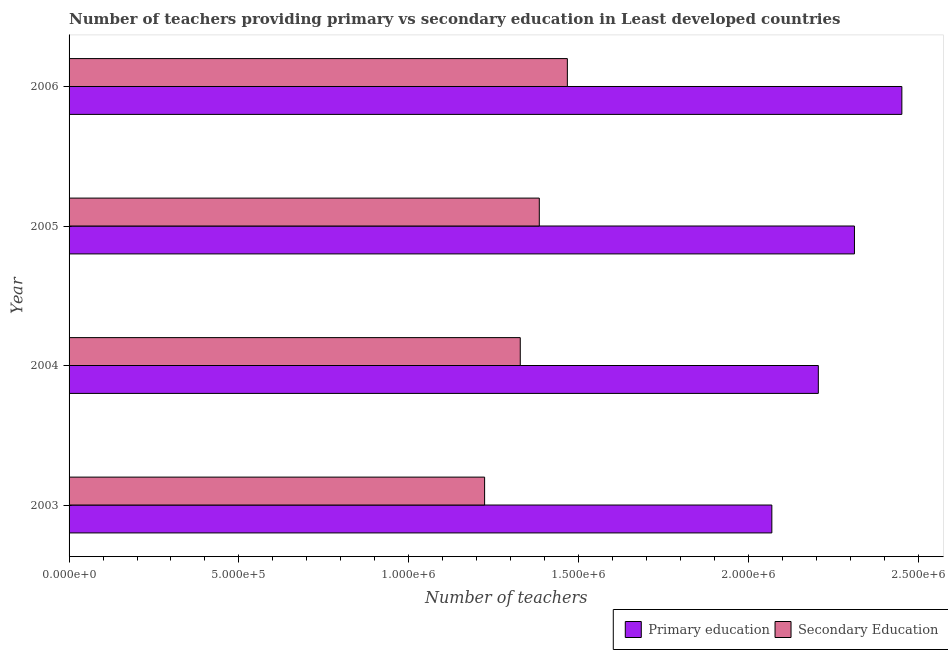How many different coloured bars are there?
Your answer should be very brief. 2. How many groups of bars are there?
Your answer should be very brief. 4. Are the number of bars on each tick of the Y-axis equal?
Keep it short and to the point. Yes. How many bars are there on the 3rd tick from the top?
Provide a short and direct response. 2. How many bars are there on the 4th tick from the bottom?
Your response must be concise. 2. What is the label of the 2nd group of bars from the top?
Make the answer very short. 2005. In how many cases, is the number of bars for a given year not equal to the number of legend labels?
Offer a terse response. 0. What is the number of secondary teachers in 2006?
Your answer should be very brief. 1.47e+06. Across all years, what is the maximum number of primary teachers?
Offer a terse response. 2.45e+06. Across all years, what is the minimum number of secondary teachers?
Keep it short and to the point. 1.22e+06. In which year was the number of primary teachers maximum?
Give a very brief answer. 2006. In which year was the number of secondary teachers minimum?
Your response must be concise. 2003. What is the total number of secondary teachers in the graph?
Ensure brevity in your answer.  5.40e+06. What is the difference between the number of secondary teachers in 2004 and that in 2005?
Your answer should be compact. -5.61e+04. What is the difference between the number of primary teachers in 2004 and the number of secondary teachers in 2006?
Offer a very short reply. 7.39e+05. What is the average number of primary teachers per year?
Offer a terse response. 2.26e+06. In the year 2004, what is the difference between the number of primary teachers and number of secondary teachers?
Your answer should be compact. 8.78e+05. In how many years, is the number of primary teachers greater than 900000 ?
Your answer should be compact. 4. What is the ratio of the number of secondary teachers in 2005 to that in 2006?
Offer a terse response. 0.94. Is the number of primary teachers in 2003 less than that in 2005?
Your answer should be very brief. Yes. Is the difference between the number of secondary teachers in 2005 and 2006 greater than the difference between the number of primary teachers in 2005 and 2006?
Your response must be concise. Yes. What is the difference between the highest and the second highest number of secondary teachers?
Offer a very short reply. 8.26e+04. What is the difference between the highest and the lowest number of primary teachers?
Your answer should be very brief. 3.83e+05. In how many years, is the number of secondary teachers greater than the average number of secondary teachers taken over all years?
Offer a very short reply. 2. What does the 2nd bar from the bottom in 2004 represents?
Provide a succinct answer. Secondary Education. How many bars are there?
Your response must be concise. 8. What is the difference between two consecutive major ticks on the X-axis?
Your response must be concise. 5.00e+05. Does the graph contain any zero values?
Offer a terse response. No. Does the graph contain grids?
Ensure brevity in your answer.  No. Where does the legend appear in the graph?
Provide a short and direct response. Bottom right. How many legend labels are there?
Your answer should be compact. 2. How are the legend labels stacked?
Offer a terse response. Horizontal. What is the title of the graph?
Offer a very short reply. Number of teachers providing primary vs secondary education in Least developed countries. What is the label or title of the X-axis?
Your response must be concise. Number of teachers. What is the label or title of the Y-axis?
Make the answer very short. Year. What is the Number of teachers of Primary education in 2003?
Offer a terse response. 2.07e+06. What is the Number of teachers in Secondary Education in 2003?
Make the answer very short. 1.22e+06. What is the Number of teachers of Primary education in 2004?
Give a very brief answer. 2.21e+06. What is the Number of teachers of Secondary Education in 2004?
Offer a terse response. 1.33e+06. What is the Number of teachers of Primary education in 2005?
Your answer should be very brief. 2.31e+06. What is the Number of teachers in Secondary Education in 2005?
Offer a very short reply. 1.38e+06. What is the Number of teachers of Primary education in 2006?
Provide a short and direct response. 2.45e+06. What is the Number of teachers of Secondary Education in 2006?
Provide a short and direct response. 1.47e+06. Across all years, what is the maximum Number of teachers of Primary education?
Keep it short and to the point. 2.45e+06. Across all years, what is the maximum Number of teachers in Secondary Education?
Make the answer very short. 1.47e+06. Across all years, what is the minimum Number of teachers of Primary education?
Provide a succinct answer. 2.07e+06. Across all years, what is the minimum Number of teachers in Secondary Education?
Give a very brief answer. 1.22e+06. What is the total Number of teachers of Primary education in the graph?
Your response must be concise. 9.04e+06. What is the total Number of teachers in Secondary Education in the graph?
Your response must be concise. 5.40e+06. What is the difference between the Number of teachers of Primary education in 2003 and that in 2004?
Your response must be concise. -1.37e+05. What is the difference between the Number of teachers in Secondary Education in 2003 and that in 2004?
Give a very brief answer. -1.05e+05. What is the difference between the Number of teachers in Primary education in 2003 and that in 2005?
Your response must be concise. -2.43e+05. What is the difference between the Number of teachers in Secondary Education in 2003 and that in 2005?
Offer a very short reply. -1.61e+05. What is the difference between the Number of teachers in Primary education in 2003 and that in 2006?
Your response must be concise. -3.83e+05. What is the difference between the Number of teachers of Secondary Education in 2003 and that in 2006?
Offer a very short reply. -2.44e+05. What is the difference between the Number of teachers in Primary education in 2004 and that in 2005?
Give a very brief answer. -1.06e+05. What is the difference between the Number of teachers in Secondary Education in 2004 and that in 2005?
Offer a terse response. -5.61e+04. What is the difference between the Number of teachers of Primary education in 2004 and that in 2006?
Your answer should be very brief. -2.46e+05. What is the difference between the Number of teachers in Secondary Education in 2004 and that in 2006?
Provide a short and direct response. -1.39e+05. What is the difference between the Number of teachers of Primary education in 2005 and that in 2006?
Make the answer very short. -1.40e+05. What is the difference between the Number of teachers of Secondary Education in 2005 and that in 2006?
Offer a very short reply. -8.26e+04. What is the difference between the Number of teachers in Primary education in 2003 and the Number of teachers in Secondary Education in 2004?
Give a very brief answer. 7.41e+05. What is the difference between the Number of teachers in Primary education in 2003 and the Number of teachers in Secondary Education in 2005?
Keep it short and to the point. 6.85e+05. What is the difference between the Number of teachers in Primary education in 2003 and the Number of teachers in Secondary Education in 2006?
Offer a very short reply. 6.02e+05. What is the difference between the Number of teachers in Primary education in 2004 and the Number of teachers in Secondary Education in 2005?
Your answer should be compact. 8.22e+05. What is the difference between the Number of teachers in Primary education in 2004 and the Number of teachers in Secondary Education in 2006?
Offer a terse response. 7.39e+05. What is the difference between the Number of teachers of Primary education in 2005 and the Number of teachers of Secondary Education in 2006?
Your answer should be compact. 8.45e+05. What is the average Number of teachers in Primary education per year?
Ensure brevity in your answer.  2.26e+06. What is the average Number of teachers in Secondary Education per year?
Ensure brevity in your answer.  1.35e+06. In the year 2003, what is the difference between the Number of teachers of Primary education and Number of teachers of Secondary Education?
Provide a short and direct response. 8.46e+05. In the year 2004, what is the difference between the Number of teachers of Primary education and Number of teachers of Secondary Education?
Your answer should be compact. 8.78e+05. In the year 2005, what is the difference between the Number of teachers in Primary education and Number of teachers in Secondary Education?
Your answer should be compact. 9.28e+05. In the year 2006, what is the difference between the Number of teachers in Primary education and Number of teachers in Secondary Education?
Give a very brief answer. 9.85e+05. What is the ratio of the Number of teachers in Primary education in 2003 to that in 2004?
Make the answer very short. 0.94. What is the ratio of the Number of teachers in Secondary Education in 2003 to that in 2004?
Your answer should be compact. 0.92. What is the ratio of the Number of teachers of Primary education in 2003 to that in 2005?
Keep it short and to the point. 0.89. What is the ratio of the Number of teachers of Secondary Education in 2003 to that in 2005?
Give a very brief answer. 0.88. What is the ratio of the Number of teachers in Primary education in 2003 to that in 2006?
Your answer should be compact. 0.84. What is the ratio of the Number of teachers of Secondary Education in 2003 to that in 2006?
Offer a terse response. 0.83. What is the ratio of the Number of teachers in Primary education in 2004 to that in 2005?
Make the answer very short. 0.95. What is the ratio of the Number of teachers in Secondary Education in 2004 to that in 2005?
Offer a very short reply. 0.96. What is the ratio of the Number of teachers in Primary education in 2004 to that in 2006?
Keep it short and to the point. 0.9. What is the ratio of the Number of teachers in Secondary Education in 2004 to that in 2006?
Offer a terse response. 0.91. What is the ratio of the Number of teachers in Primary education in 2005 to that in 2006?
Keep it short and to the point. 0.94. What is the ratio of the Number of teachers in Secondary Education in 2005 to that in 2006?
Provide a succinct answer. 0.94. What is the difference between the highest and the second highest Number of teachers in Primary education?
Offer a very short reply. 1.40e+05. What is the difference between the highest and the second highest Number of teachers in Secondary Education?
Your answer should be very brief. 8.26e+04. What is the difference between the highest and the lowest Number of teachers in Primary education?
Provide a short and direct response. 3.83e+05. What is the difference between the highest and the lowest Number of teachers of Secondary Education?
Provide a short and direct response. 2.44e+05. 